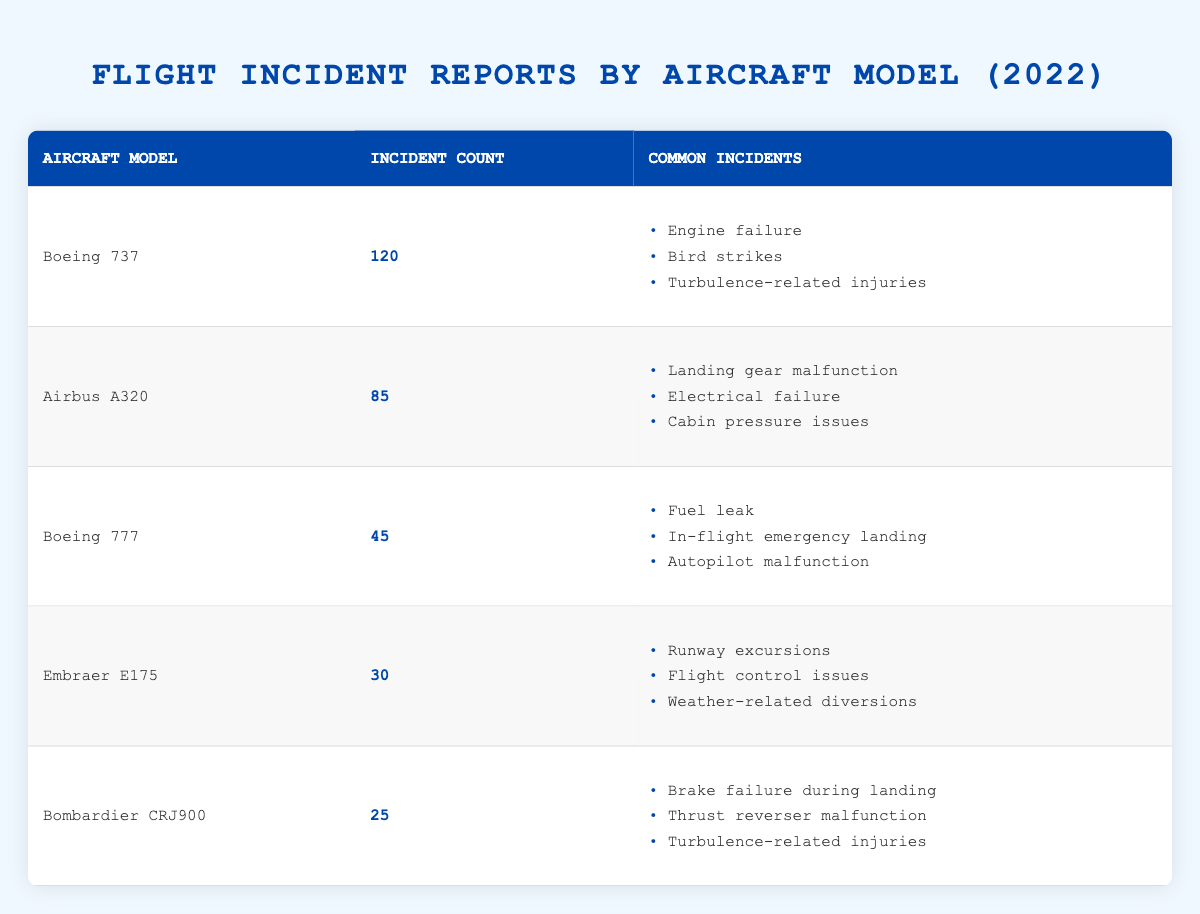What is the incident count for the Boeing 737? From the table, under the "Incident Count" column for the "Boeing 737" row, the value is 120.
Answer: 120 Which aircraft model has the highest number of incidents? By comparing the "Incident Count" values across all rows, the highest value is for "Boeing 737," which has 120 incidents.
Answer: Boeing 737 What are the common incidents reported for the Airbus A320? In the table, the "Common Incidents" listed for the "Airbus A320" model are: 1) Landing gear malfunction 2) Electrical failure 3) Cabin pressure issues.
Answer: Landing gear malfunction, Electrical failure, Cabin pressure issues How many total incidents are reported across all aircraft models? To find the total incidents, sum the "Incident Count" values: 120 (Boeing 737) + 85 (Airbus A320) + 45 (Boeing 777) + 30 (Embraer E175) + 25 (Bombardier CRJ900) = 120 + 85 + 45 + 30 + 25 = 305.
Answer: 305 Is it true that the Bombardier CRJ900 has more incidents than the Embraer E175? Comparing the incident counts, the "Bombardier CRJ900" has 25 incidents and the "Embraer E175" has 30 incidents, which means the statement is false.
Answer: No What is the average number of incidents for all aircraft models? To calculate the average, first sum the incident counts (305) then divide by the number of models (5): 305/5 = 61. Therefore, the average is 61 incidents.
Answer: 61 Which aircraft model has the lowest number of incidents, and what is that number? By examining the incident counts, "Bombardier CRJ900" has the lowest count at 25 incidents.
Answer: Bombardier CRJ900, 25 Does the Boeing 777 have any incidents related to engine failure? The common incidents for the "Boeing 777" listed in the table are: Fuel leak, in-flight emergency landing, and autopilot malfunction, none of which mention engine failure.
Answer: No How many common incidents are reported for the Embraer E175? The table indicates that the "Embraer E175" has three common incidents listed: Runway excursions, flight control issues, and weather-related diversions, amounting to a total of three.
Answer: 3 